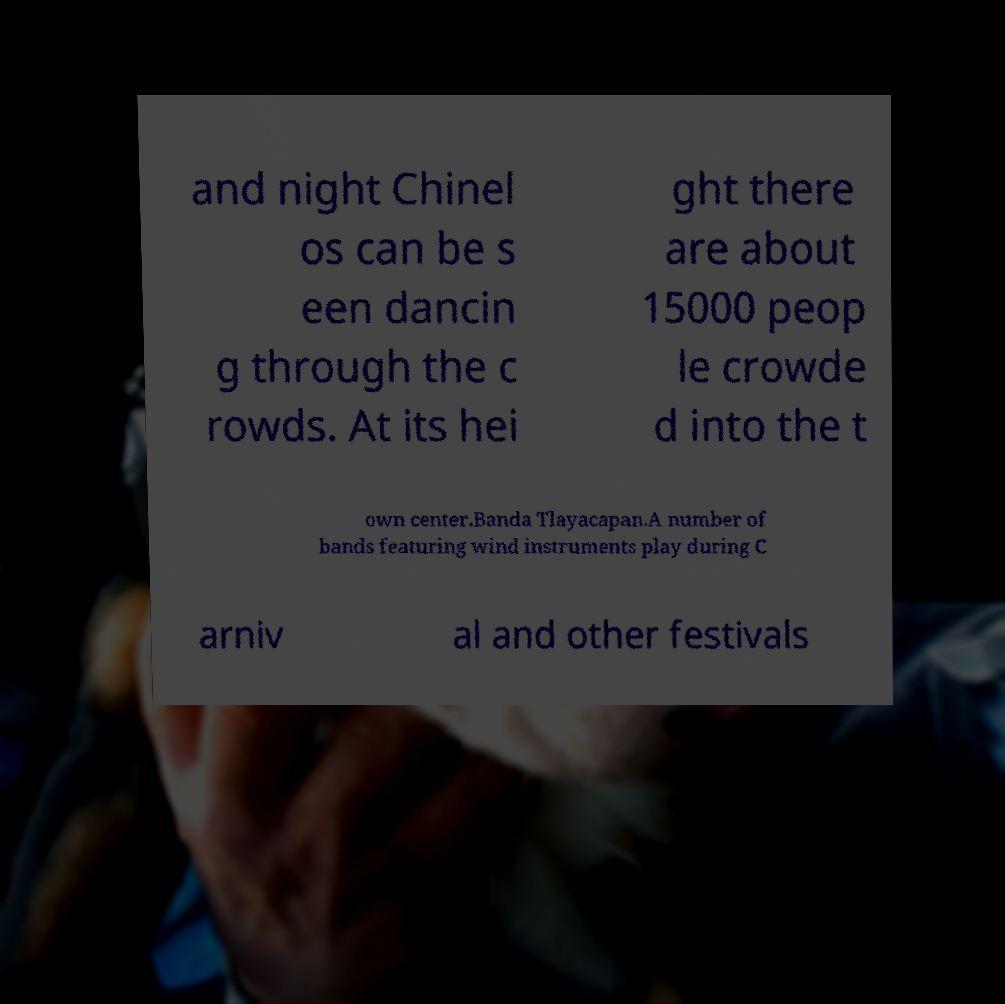What messages or text are displayed in this image? I need them in a readable, typed format. and night Chinel os can be s een dancin g through the c rowds. At its hei ght there are about 15000 peop le crowde d into the t own center.Banda Tlayacapan.A number of bands featuring wind instruments play during C arniv al and other festivals 